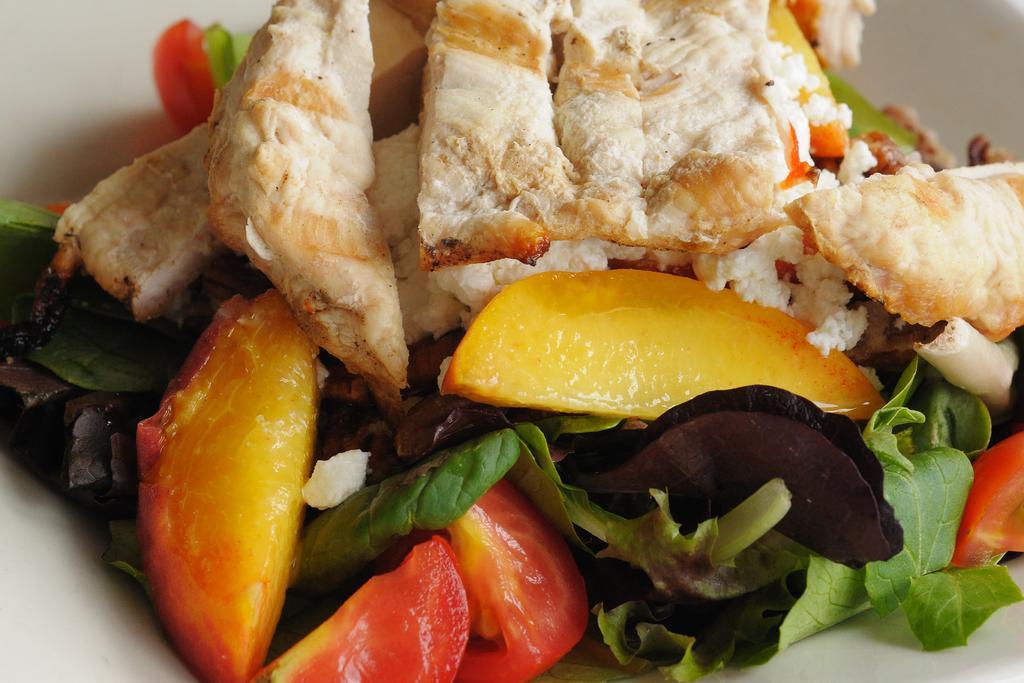Can you describe this image briefly? There is a food kept in a white color bowl as we can see in the middle of this image. 